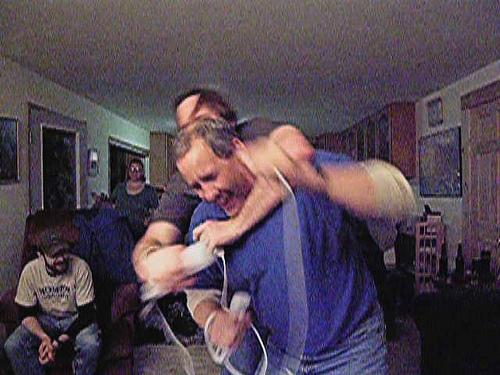What are the two men doing? wrestling 